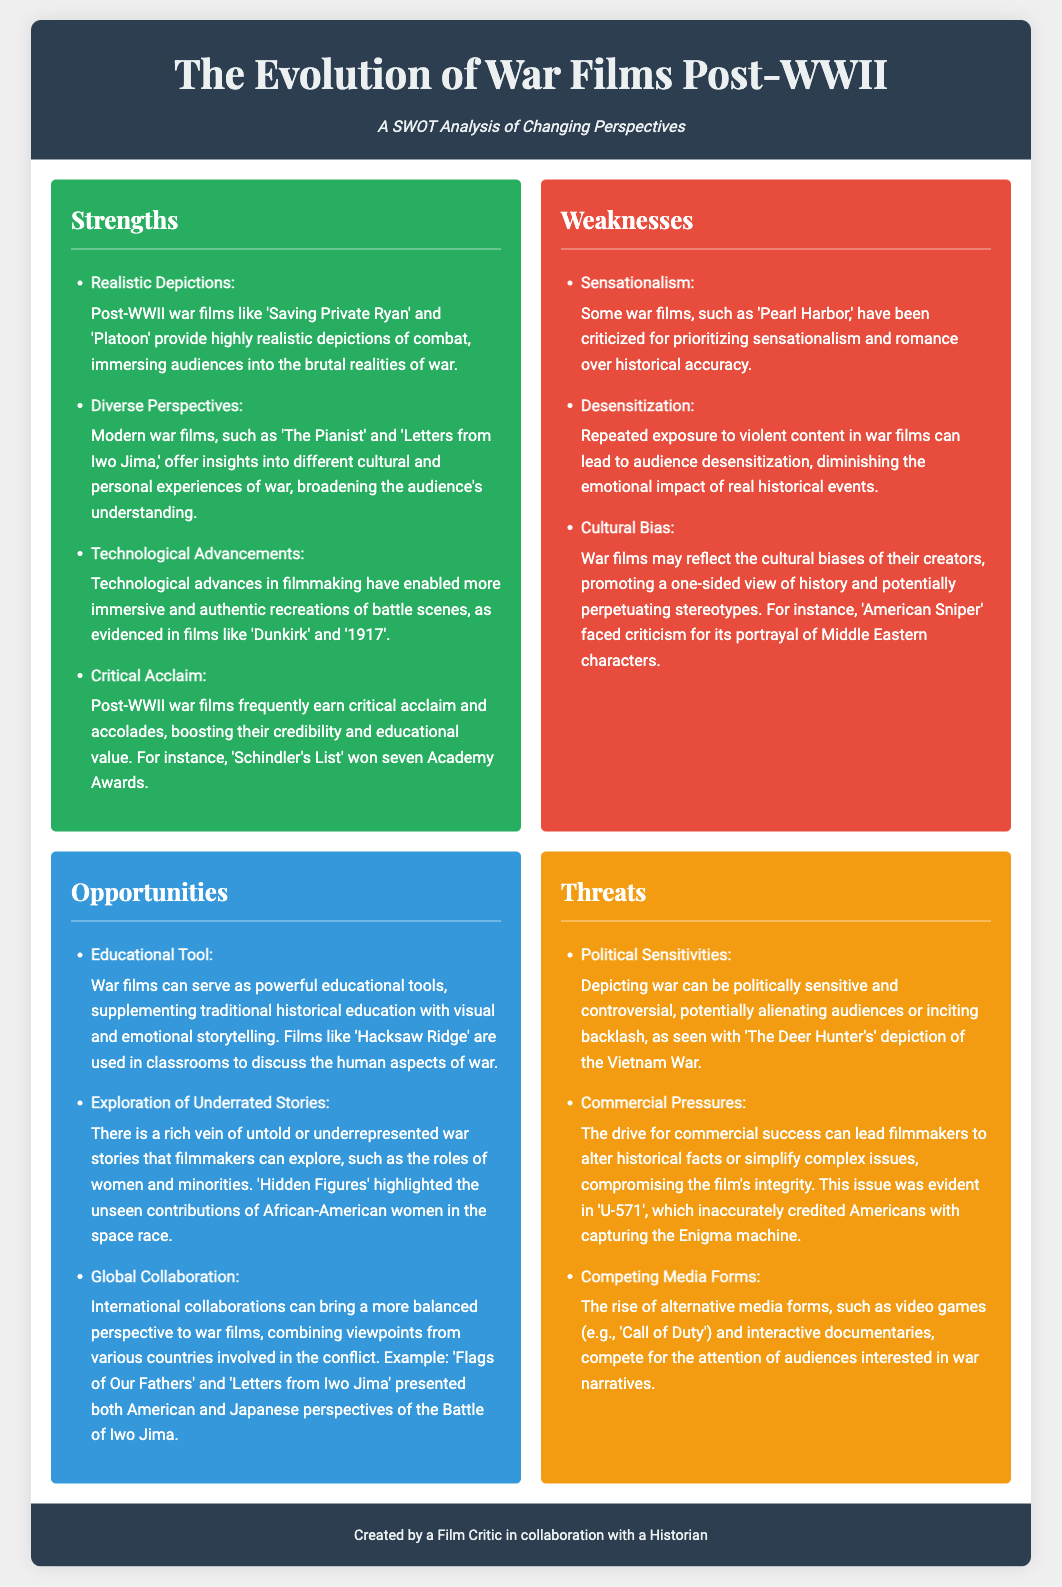What is one war film that provides a highly realistic depiction of combat? 'Saving Private Ryan' and 'Platoon' are cited as war films providing highly realistic depictions of combat in the document.
Answer: 'Saving Private Ryan' Name one technological advancement mentioned that enhances battle scenes in war films. The document discusses how technological advances in filmmaking contribute to immersive recreations of battle scenes.
Answer: Technological advancements What is a criticism faced by the film 'American Sniper'? The document mentions that 'American Sniper' faced criticism for its portrayal of Middle Eastern characters, reflecting cultural bias.
Answer: Cultural bias Which film won seven Academy Awards? The document states that 'Schindler's List' won seven Academy Awards, showcasing its critical acclaim.
Answer: 'Schindler's List' What opportunity do war films have as educational tools? The analysis indicates that war films can supplement traditional historical education through visual storytelling, as seen with 'Hacksaw Ridge'.
Answer: Educational tool What is a potential threat related to commercial pressures on war films? The document highlights that commercial success can lead filmmakers to alter historical facts or simplify complex issues, compromising integrity.
Answer: Altering historical facts Identify one underrepresented story that filmmakers can explore in war films. The document mentions that the roles of women and minorities are examples of underrepresented stories that could be explored in war films.
Answer: Roles of women and minorities Which two films presented both American and Japanese perspectives of combat? 'Flags of Our Fathers' and 'Letters from Iwo Jima' are noted for presenting dual perspectives of the Battle of Iwo Jima in the document.
Answer: 'Flags of Our Fathers' and 'Letters from Iwo Jima' 